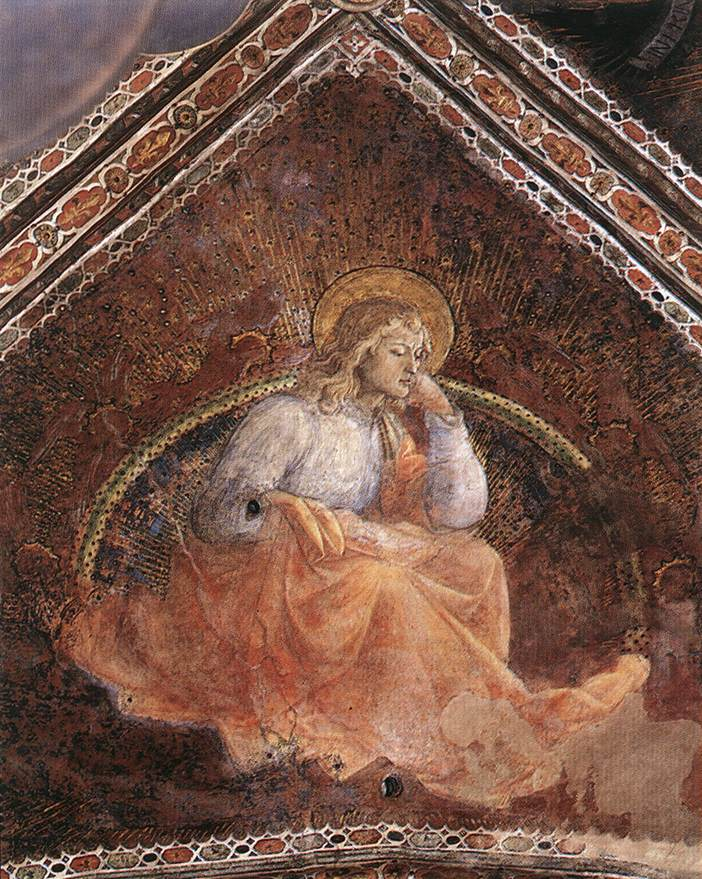Please narrate a short story inspired by this painting. In a quiet, sacred chapel adorned with frescoes of divine scenes, there sat an angel who had come down to contemplate the sorrows of the world. Draped in a robe of immaculate white, symbolizing purity, and crowned with a halo of gold, the angel pondered deeply, its celestial wings slightly unfurled. The angel’s thoughts were heavy with the whispers of human prayers and the cries for help from every corner of the earth. As it sat in the serene glow of the chapel, bathed in the interplay of light and shadow, the angel’s presence brought a sense of peace and hope to all who gazed upon it. The dark red and gold accents of the walls contrasted with the angel’s ethereal brightness, symbolizing the eternal struggle between earthly suffering and heavenly grace. Each golden fleck in the backdrop seemed to shimmer with promises of renewal and divine intervention, reflecting the boundless compassion that the angel held for the world. 